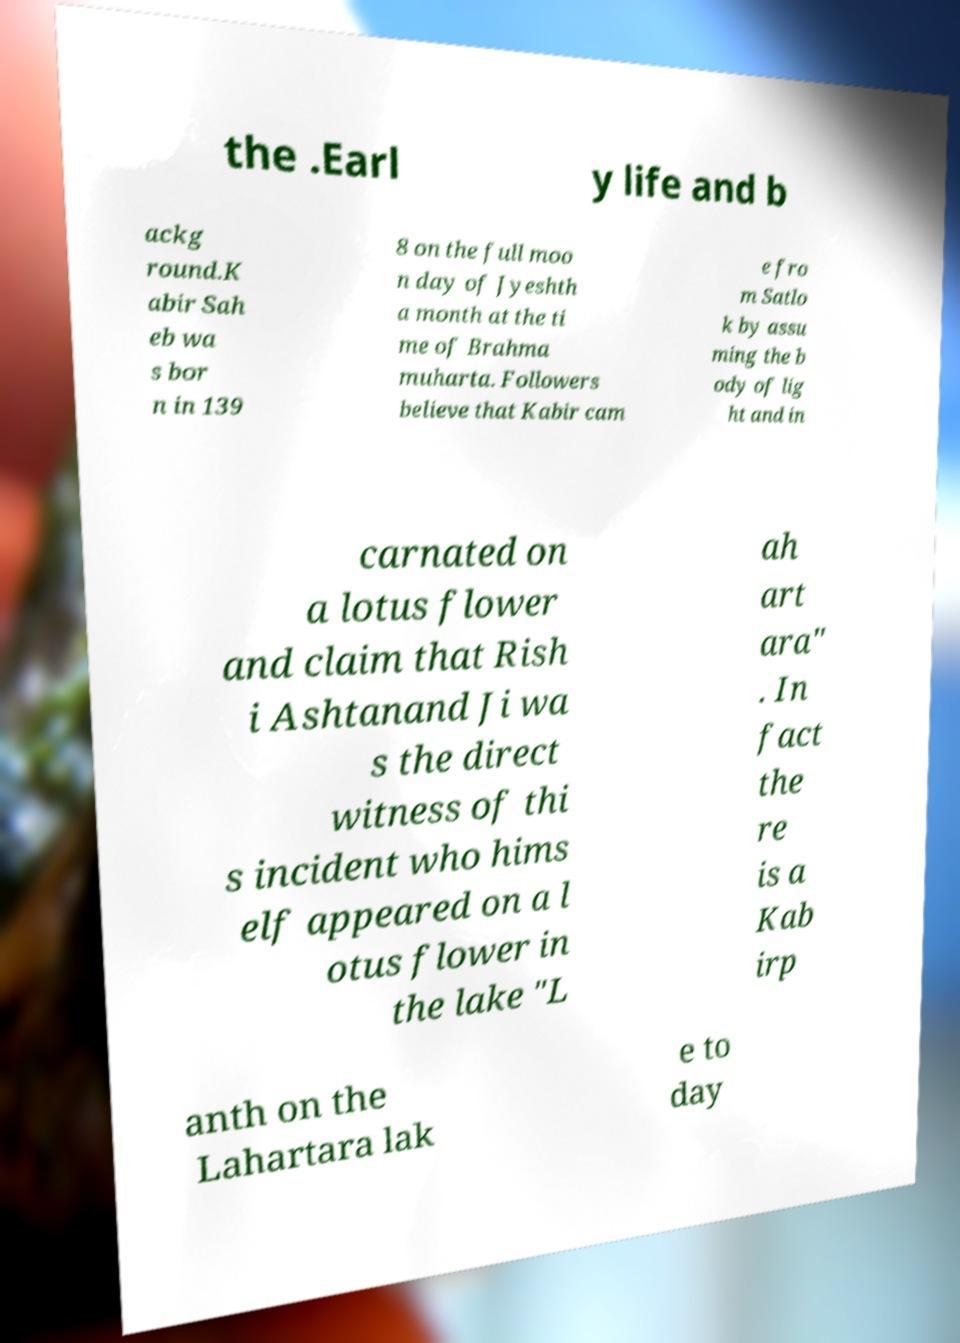I need the written content from this picture converted into text. Can you do that? the .Earl y life and b ackg round.K abir Sah eb wa s bor n in 139 8 on the full moo n day of Jyeshth a month at the ti me of Brahma muharta. Followers believe that Kabir cam e fro m Satlo k by assu ming the b ody of lig ht and in carnated on a lotus flower and claim that Rish i Ashtanand Ji wa s the direct witness of thi s incident who hims elf appeared on a l otus flower in the lake "L ah art ara" . In fact the re is a Kab irp anth on the Lahartara lak e to day 